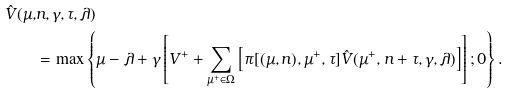Convert formula to latex. <formula><loc_0><loc_0><loc_500><loc_500>\hat { V } ( \mu , & n , \gamma , \tau , \lambda ) \\ & = \max \left \{ \mu - \lambda + \gamma \left [ V ^ { + } + \sum _ { \mu ^ { + } \in \Omega } \left [ \pi [ ( \mu , n ) , \mu ^ { + } , \tau ] \hat { V } ( \mu ^ { + } , n + \tau , \gamma , \lambda ) \right ] \right ] ; 0 \right \} .</formula> 